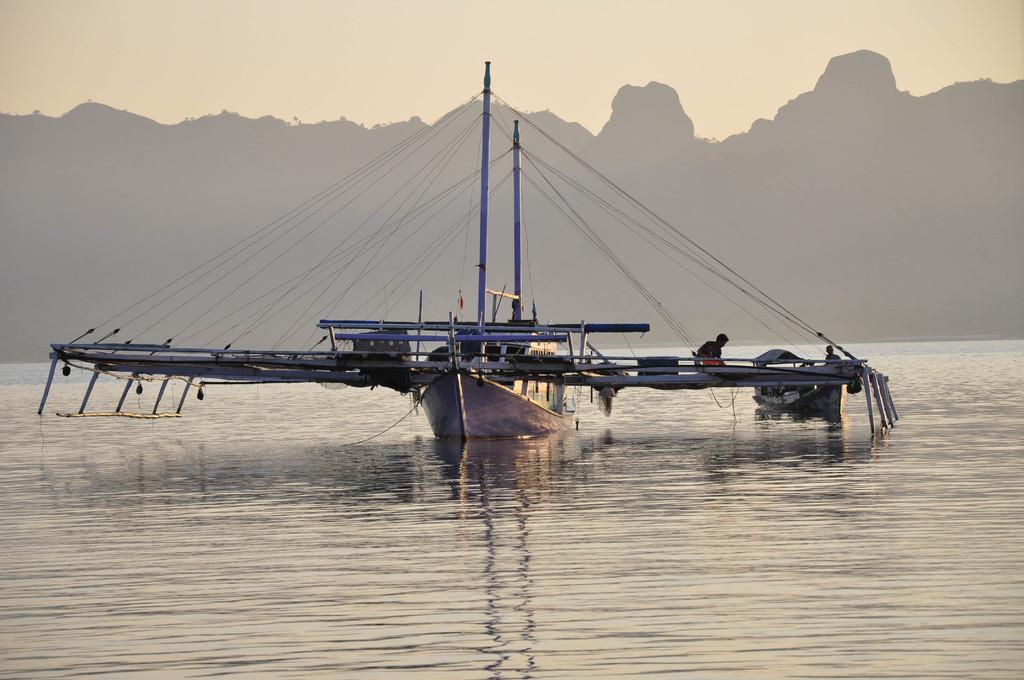Please provide a concise description of this image. In this picture we can see boats on water, poles, two people and some objects and in the background we can see mountains, sky. 